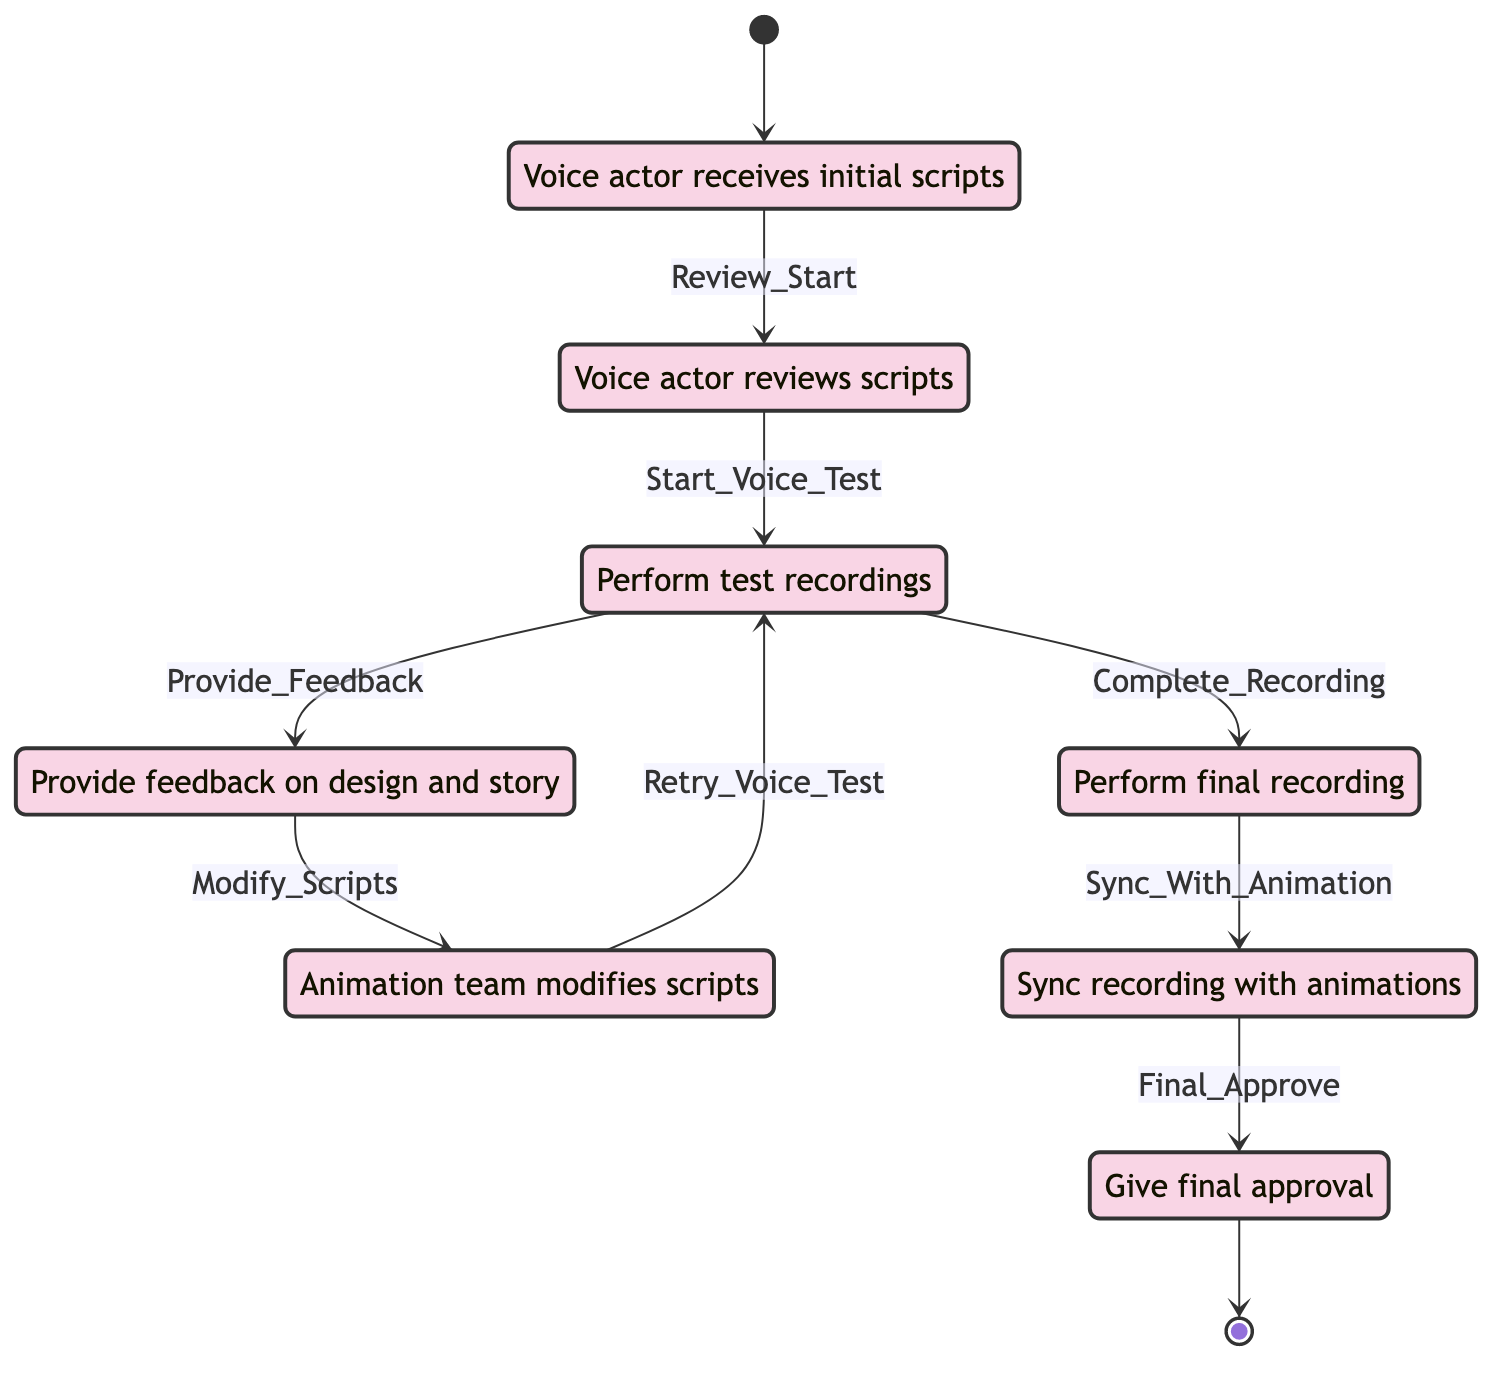What is the first state in the diagram? The first state in the diagram is clearly marked as "Receiving_Scripts," which is the initial node the voice actor interacts with.
Answer: Receiving_Scripts How many total states are there in the diagram? By counting the distinct states listed, there are a total of eight states, ranging from "Receiving_Scripts" to "Final_Approval."
Answer: 8 What transition occurs after "Voice_Testing"? The transition that occurs after "Voice_Testing" is "Provide_Feedback," which indicates the voice actor provides feedback after performing test recordings.
Answer: Provide_Feedback Which state comes right before "Final_Recording"? The state that comes right before "Final_Recording" is "Voice_Testing," indicating that final recordings occur after the test recordings are performed.
Answer: Voice_Testing What does the final state represent in the diagram? The final state in the diagram represents "Final_Approval," where the voice actor gives final approval for the character's voice in the finished animation.
Answer: Final_Approval What is the transition name from "Feedback_Provision" to "Script_Modification"? The transition from "Feedback_Provision" to "Script_Modification" is named "Modify_Scripts," signifying that the animation team modifies scripts based on feedback.
Answer: Modify_Scripts What is the relationship between "Final_Recording" and "Animation_Sync"? The relationship is defined by the transition "Sync_With_Animation," meaning that after the final recording, the animation team syncs this recording with the animations.
Answer: Sync_With_Animation What happens after "Script_Modification"? After "Script_Modification," the process can return to "Voice_Testing" through the transition "Retry_Voice_Test," indicating a cycle for further testing if needed.
Answer: Voice_Testing 